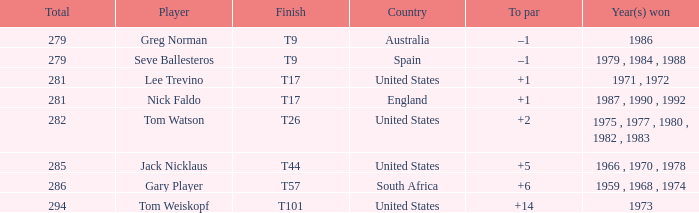Who has the highest total and a to par of +14? 294.0. 